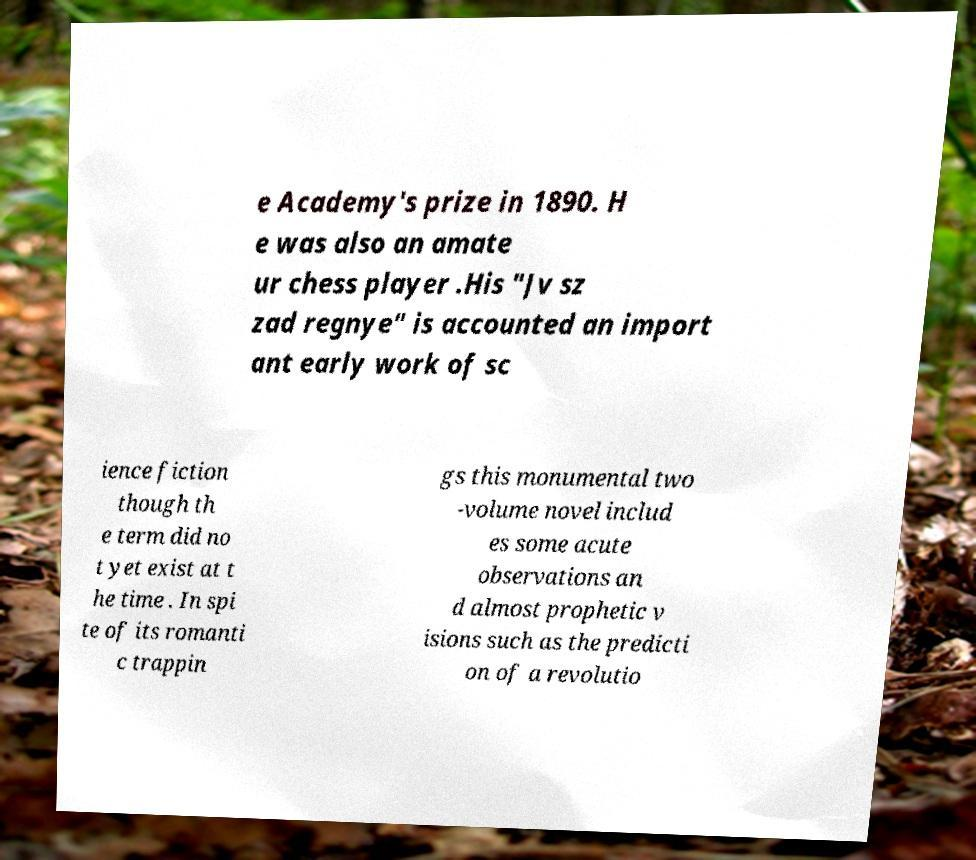Can you accurately transcribe the text from the provided image for me? e Academy's prize in 1890. H e was also an amate ur chess player .His "Jv sz zad regnye" is accounted an import ant early work of sc ience fiction though th e term did no t yet exist at t he time . In spi te of its romanti c trappin gs this monumental two -volume novel includ es some acute observations an d almost prophetic v isions such as the predicti on of a revolutio 